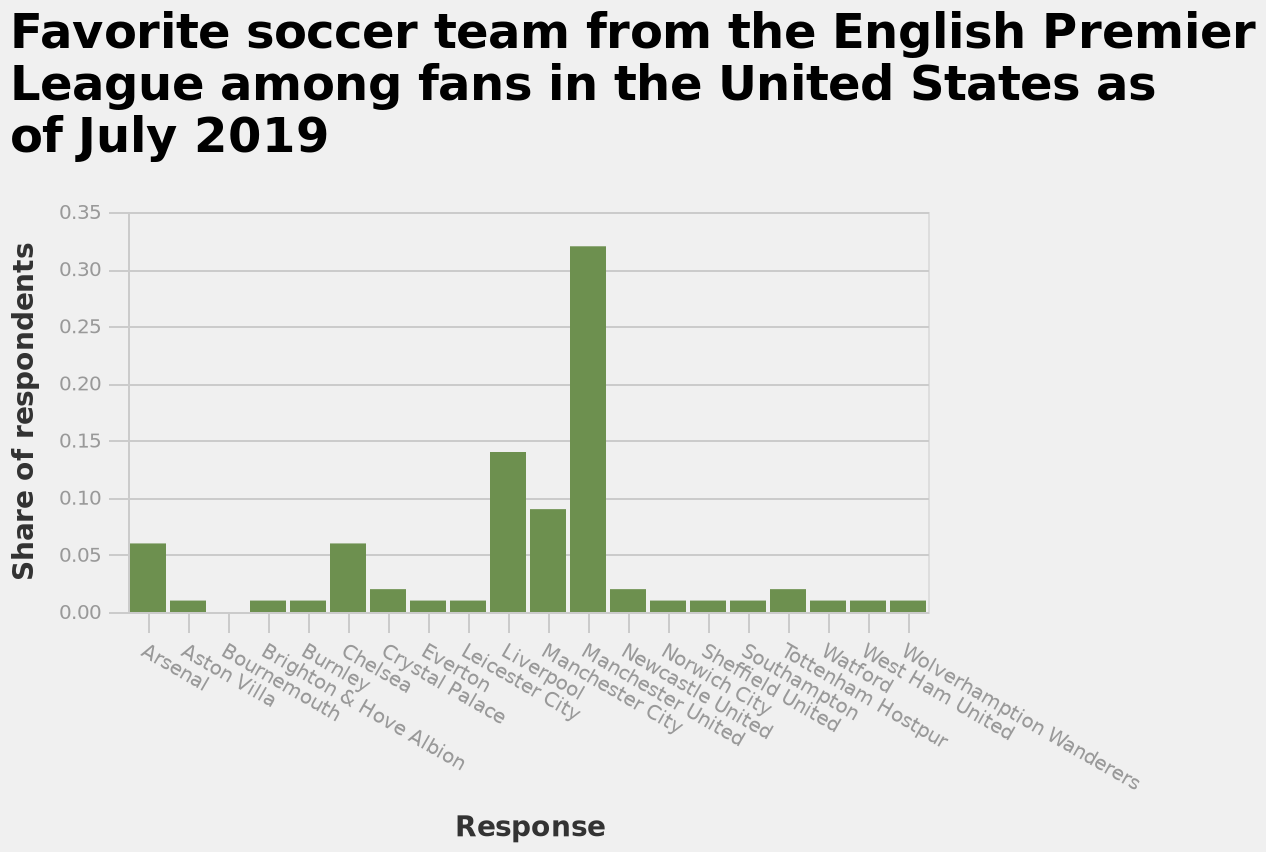<image>
please enumerates aspects of the construction of the chart This bar diagram is titled Favorite soccer team from the English Premier League among fans in the United States as of July 2019. The y-axis shows Share of respondents with scale of range 0.00 to 0.35 while the x-axis shows Response as categorical scale from Arsenal to Wolverhamption Wanderers. 